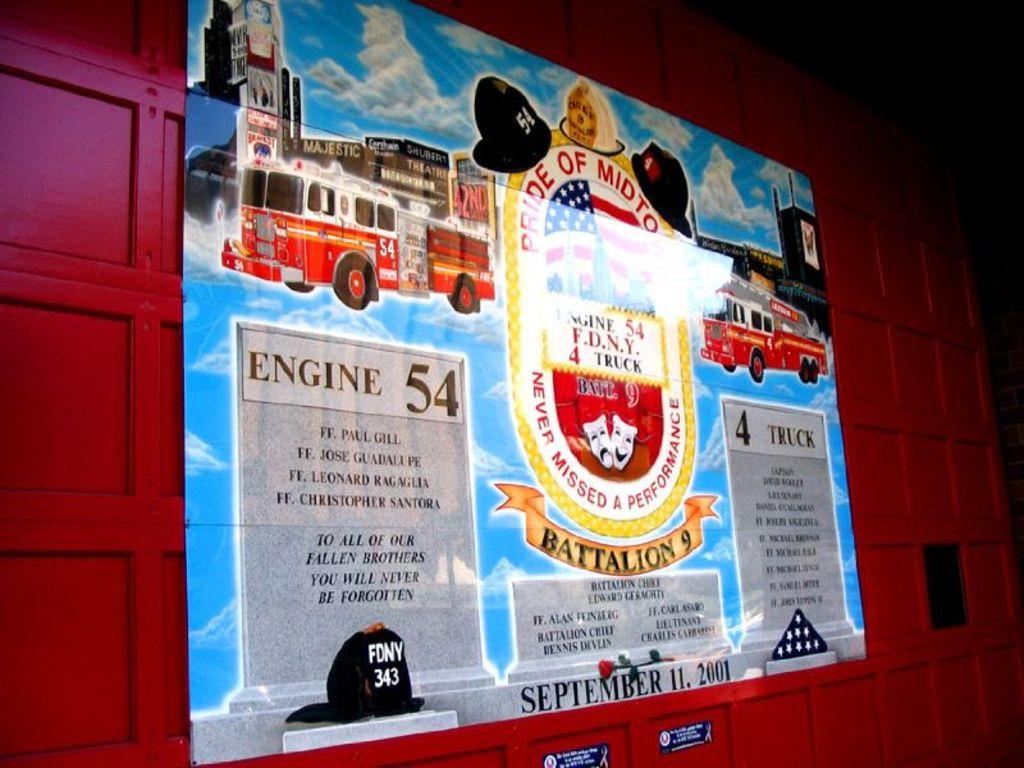Where can i find engine 54?
Your response must be concise. Battalion 9. What is the date on the bottom of the poster?
Keep it short and to the point. September 11, 2001. 